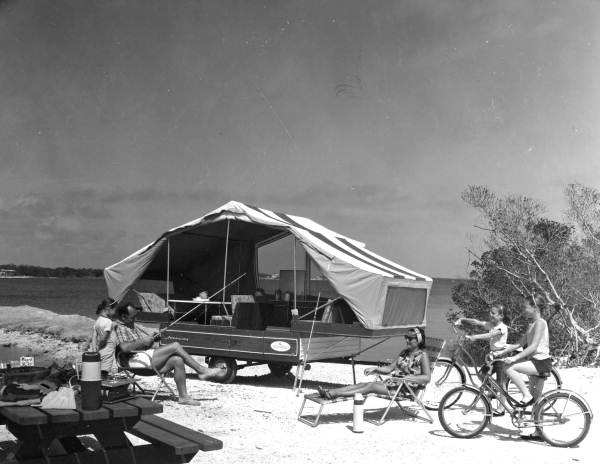Describe the objects in this image and their specific colors. I can see dining table in black, gray, lightgray, and darkgray tones, bicycle in black, white, gray, and darkgray tones, people in black, gray, darkgray, and lightgray tones, bicycle in black, white, gray, and darkgray tones, and people in black, darkgray, gray, and lightgray tones in this image. 